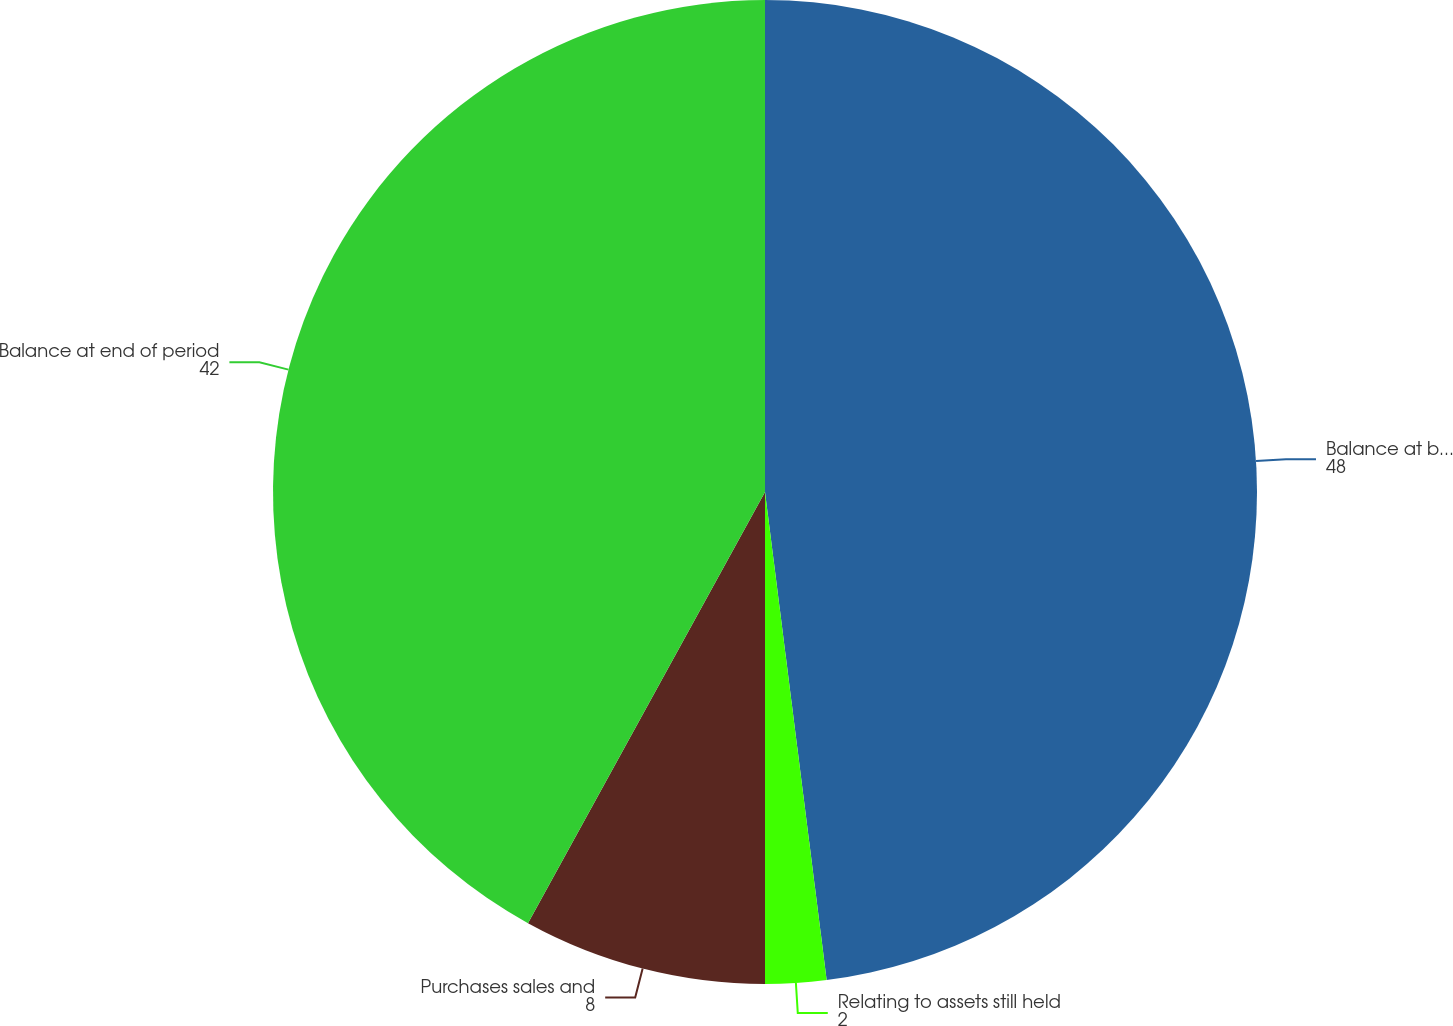<chart> <loc_0><loc_0><loc_500><loc_500><pie_chart><fcel>Balance at beginning of period<fcel>Relating to assets still held<fcel>Purchases sales and<fcel>Balance at end of period<nl><fcel>48.0%<fcel>2.0%<fcel>8.0%<fcel>42.0%<nl></chart> 